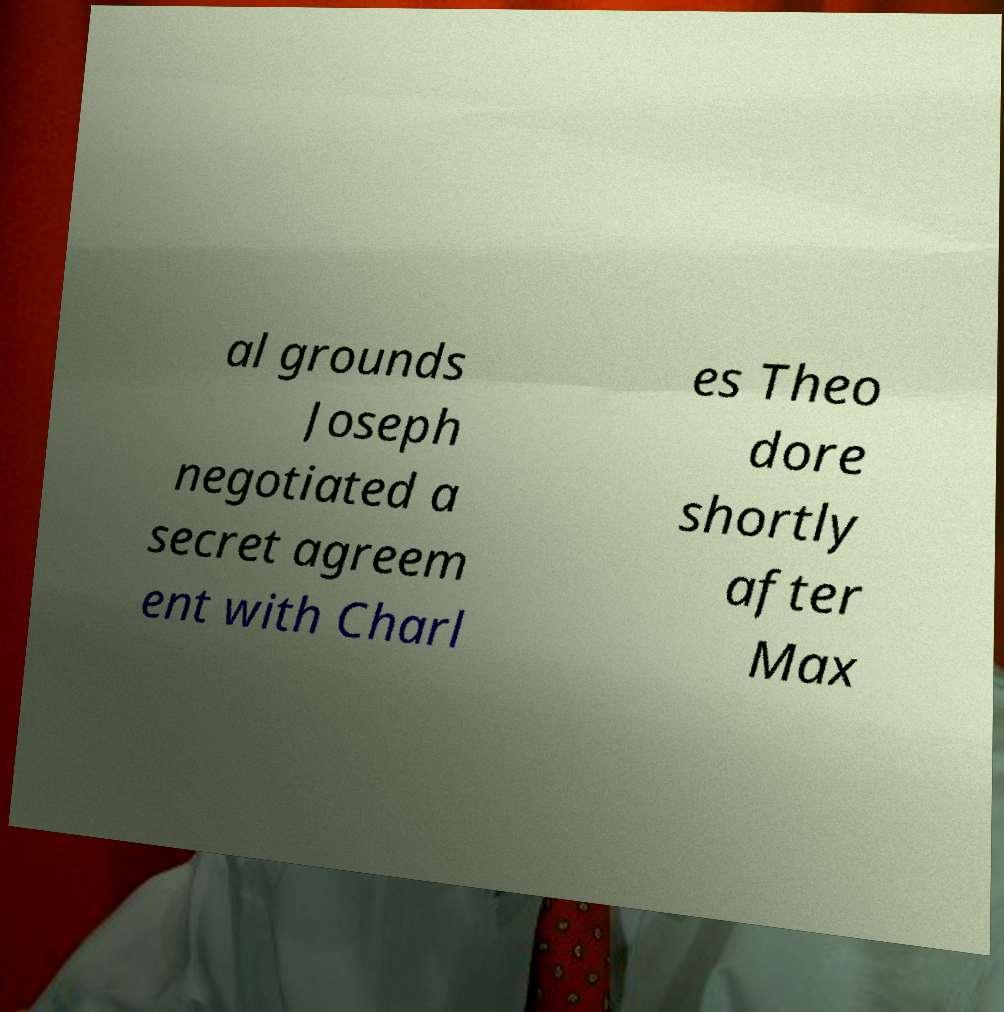What messages or text are displayed in this image? I need them in a readable, typed format. al grounds Joseph negotiated a secret agreem ent with Charl es Theo dore shortly after Max 